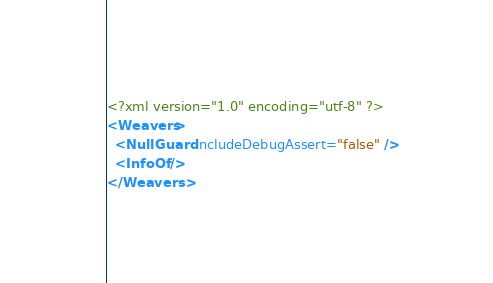Convert code to text. <code><loc_0><loc_0><loc_500><loc_500><_XML_><?xml version="1.0" encoding="utf-8" ?>
<Weavers>
  <NullGuard IncludeDebugAssert="false" />
  <InfoOf />
</Weavers></code> 